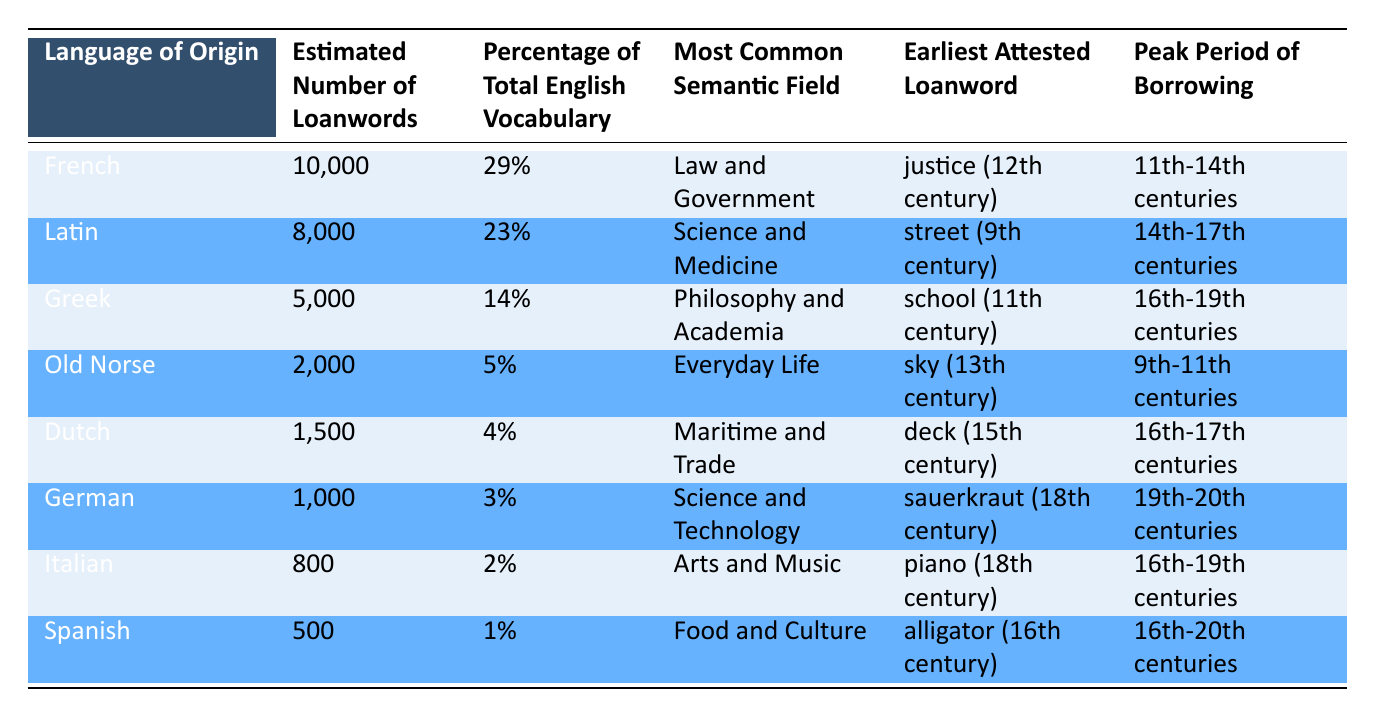What is the language of origin with the highest estimated number of loanwords? French has the highest estimated number of loanwords listed in the table, at 10,000.
Answer: French Which language contributes 29% to the total English vocabulary? French contributes 29% to the total English vocabulary according to the table.
Answer: French How many loanwords does German contribute to modern English? The table states that German contributes 1,000 loanwords to modern English.
Answer: 1,000 Which semantic field is most common for loanwords from Latin? The most common semantic field for loanwords from Latin is Science and Medicine, as specified in the table.
Answer: Science and Medicine What language has the earliest attested loanword "justice"? The earliest attested loanword "justice" comes from French, as indicated in the table.
Answer: French Which two languages have the highest and lowest estimated number of loanwords, respectively? French has the highest estimated number with 10,000 and Spanish has the lowest with 500.
Answer: French and Spanish Is it true that Spanish has the largest percentage of total English vocabulary? No, Spanish does not have the largest percentage; it only contributes 1%.
Answer: No What is the peak period of borrowing for Greek loanwords? The peak period of borrowing for Greek loanwords is listed as the 16th to 19th centuries in the table.
Answer: 16th-19th centuries What is the total estimated number of loanwords from French and Latin combined? Adding the estimated loanwords from French (10,000) and Latin (8,000) gives a total of 18,000 loanwords from these two languages.
Answer: 18,000 